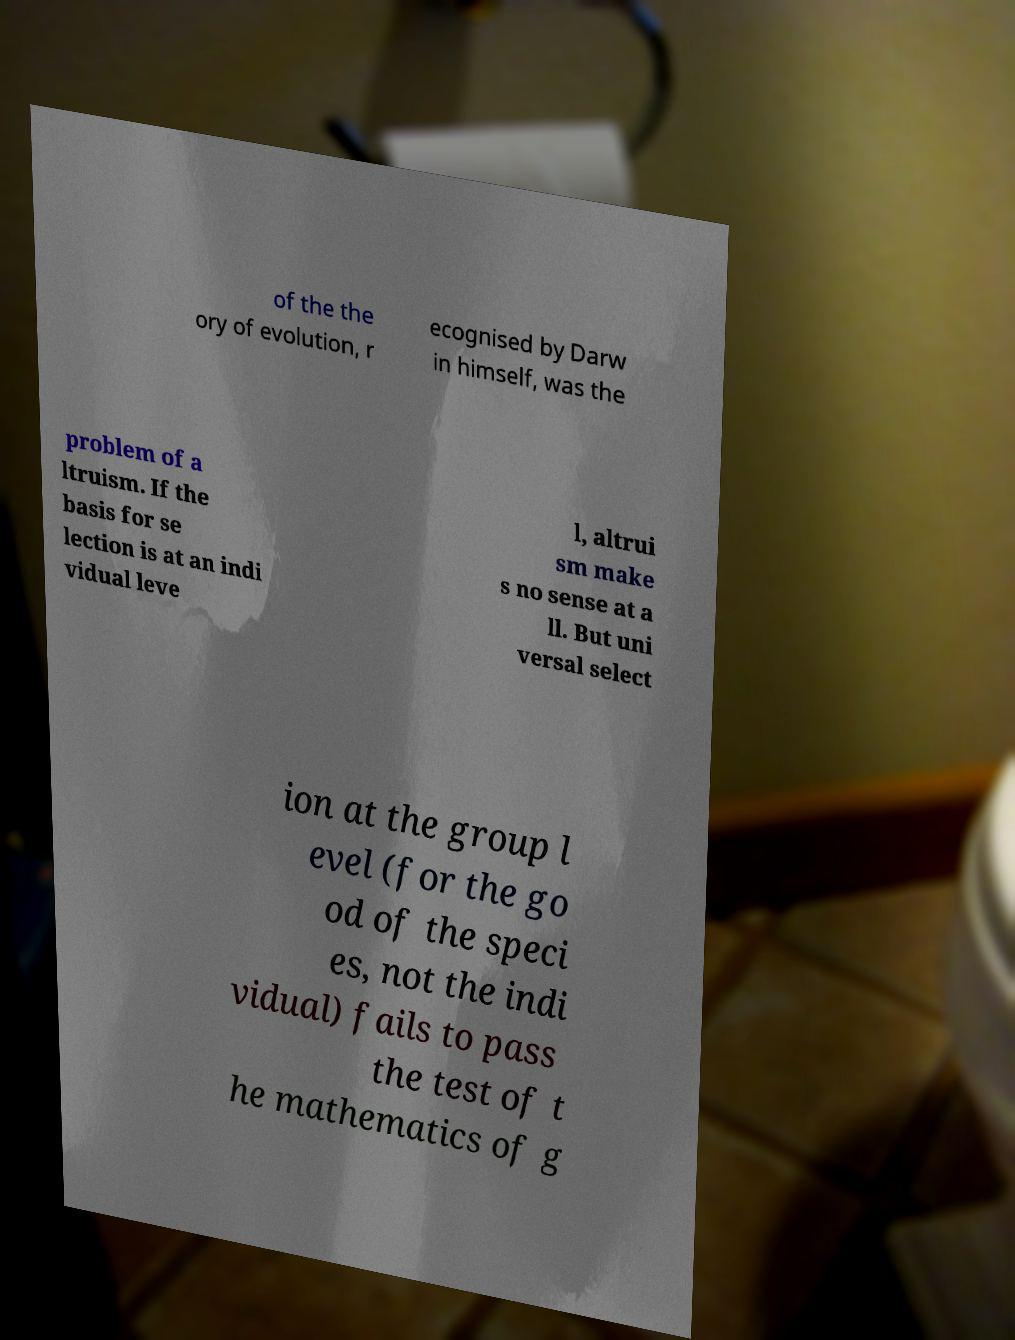I need the written content from this picture converted into text. Can you do that? of the the ory of evolution, r ecognised by Darw in himself, was the problem of a ltruism. If the basis for se lection is at an indi vidual leve l, altrui sm make s no sense at a ll. But uni versal select ion at the group l evel (for the go od of the speci es, not the indi vidual) fails to pass the test of t he mathematics of g 